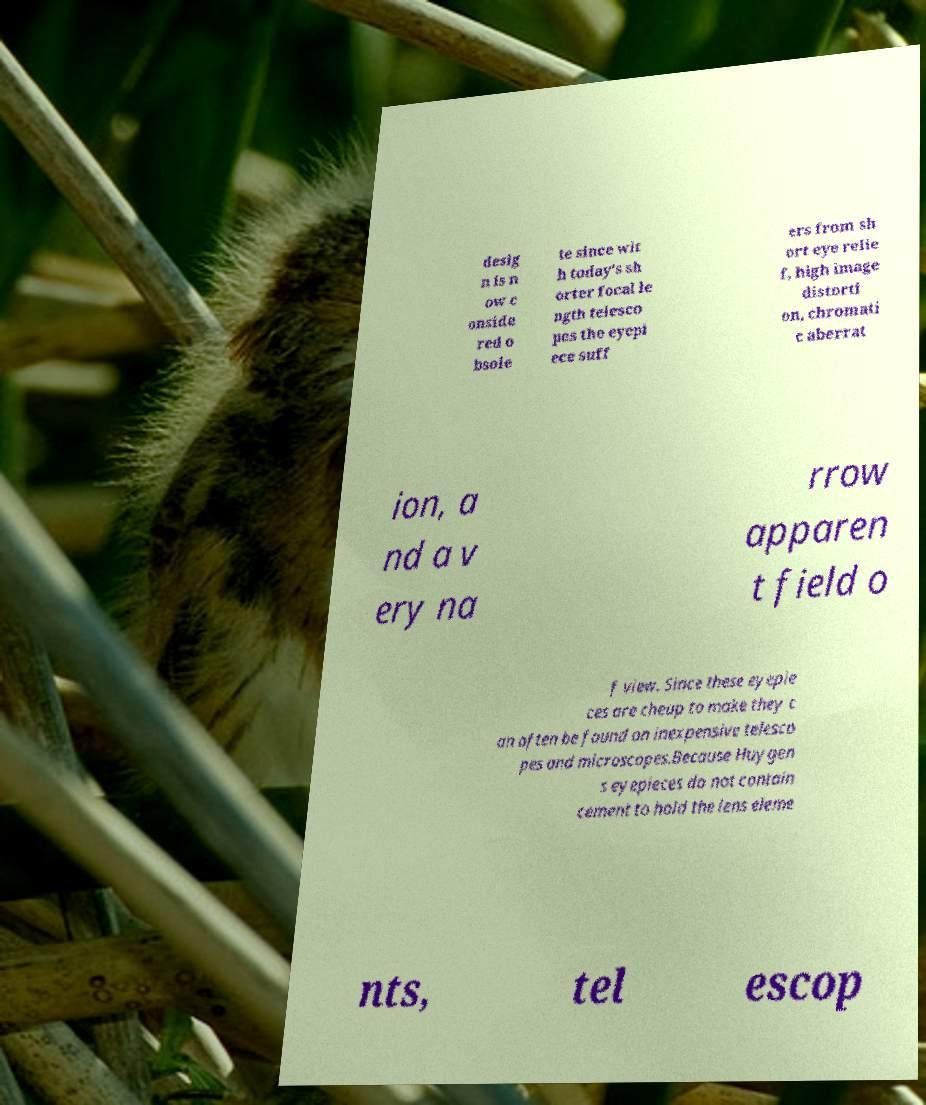I need the written content from this picture converted into text. Can you do that? desig n is n ow c onside red o bsole te since wit h today's sh orter focal le ngth telesco pes the eyepi ece suff ers from sh ort eye relie f, high image distorti on, chromati c aberrat ion, a nd a v ery na rrow apparen t field o f view. Since these eyepie ces are cheap to make they c an often be found on inexpensive telesco pes and microscopes.Because Huygen s eyepieces do not contain cement to hold the lens eleme nts, tel escop 